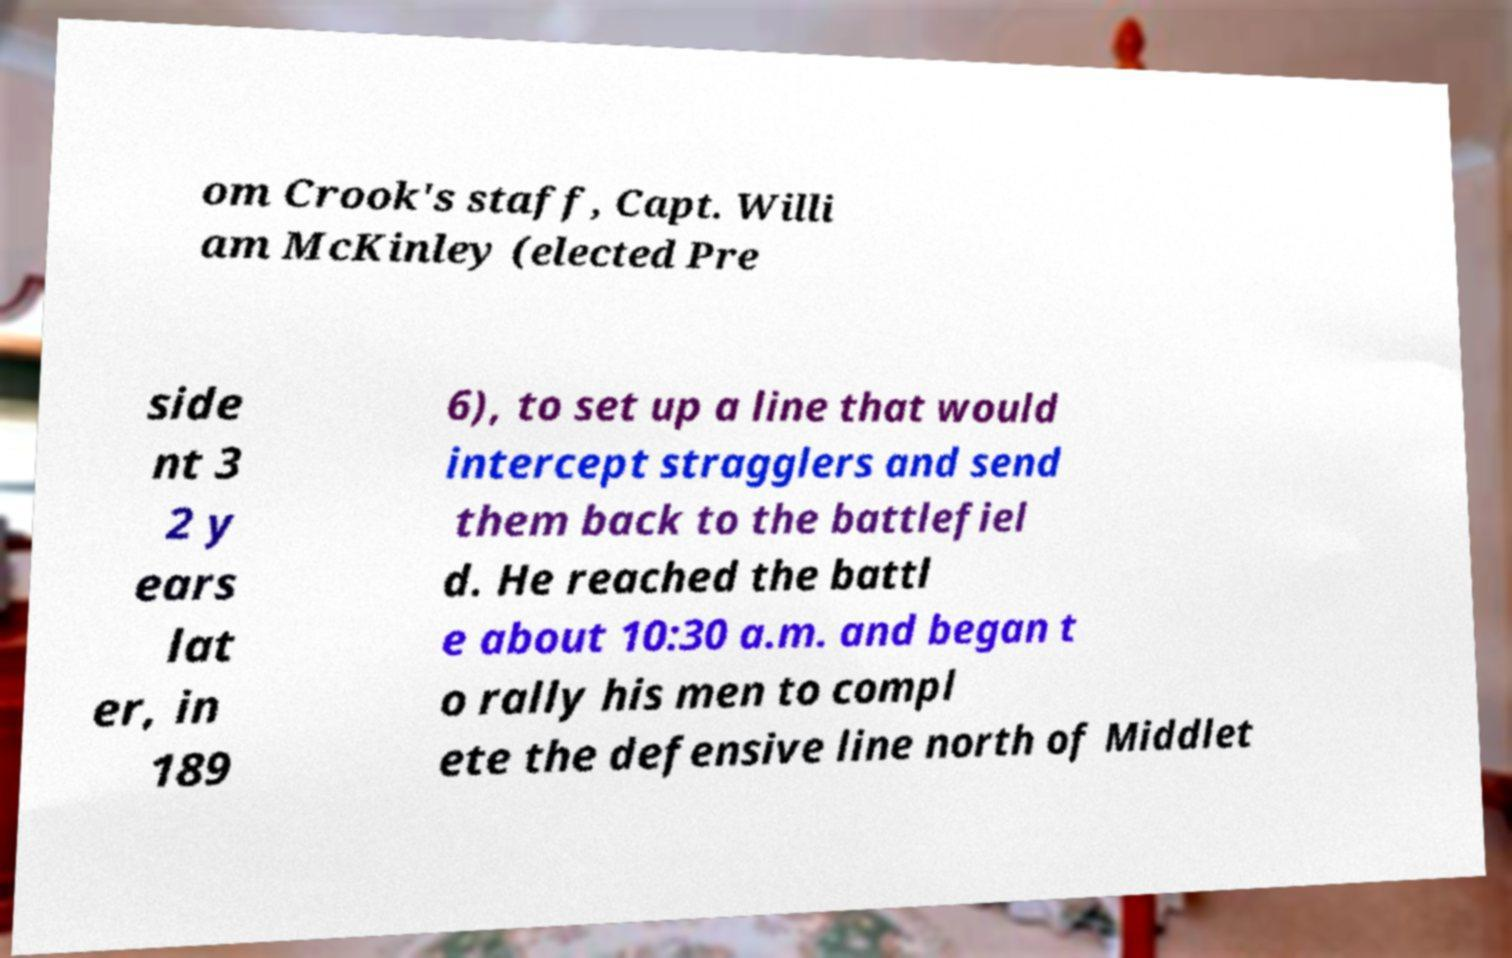I need the written content from this picture converted into text. Can you do that? om Crook's staff, Capt. Willi am McKinley (elected Pre side nt 3 2 y ears lat er, in 189 6), to set up a line that would intercept stragglers and send them back to the battlefiel d. He reached the battl e about 10:30 a.m. and began t o rally his men to compl ete the defensive line north of Middlet 